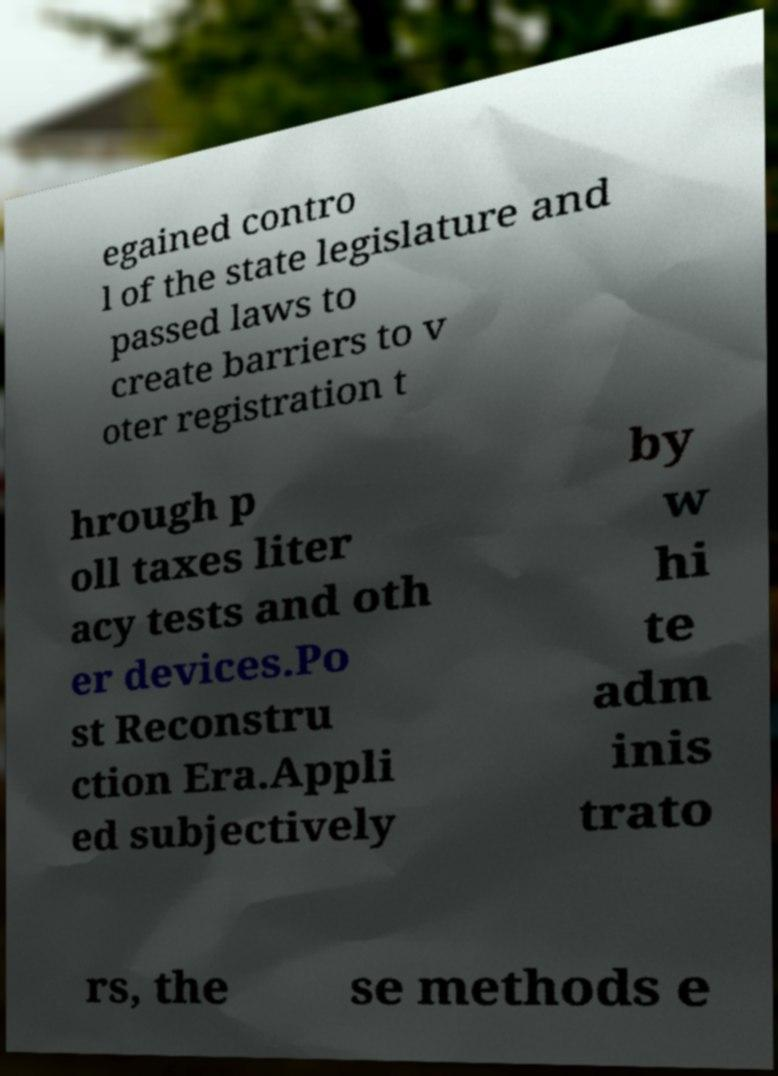Please identify and transcribe the text found in this image. egained contro l of the state legislature and passed laws to create barriers to v oter registration t hrough p oll taxes liter acy tests and oth er devices.Po st Reconstru ction Era.Appli ed subjectively by w hi te adm inis trato rs, the se methods e 